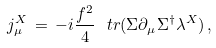<formula> <loc_0><loc_0><loc_500><loc_500>j _ { \mu } ^ { X } \, = \, - i \frac { f ^ { 2 } } { 4 } \ t r ( \Sigma \partial _ { \mu } \Sigma ^ { \dagger } \lambda ^ { X } ) \, ,</formula> 